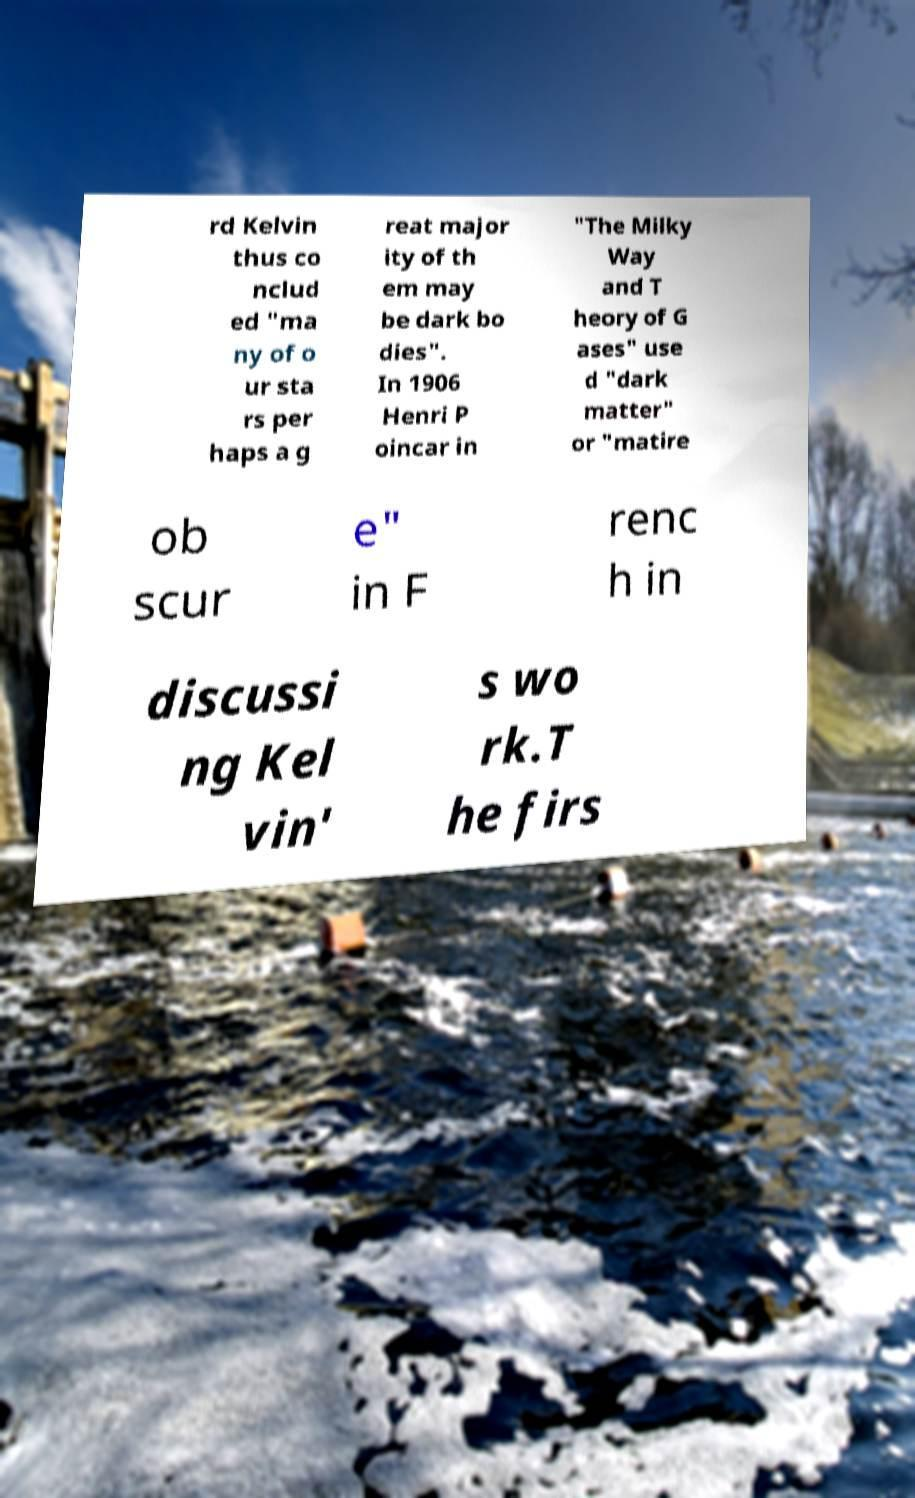Please read and relay the text visible in this image. What does it say? rd Kelvin thus co nclud ed "ma ny of o ur sta rs per haps a g reat major ity of th em may be dark bo dies". In 1906 Henri P oincar in "The Milky Way and T heory of G ases" use d "dark matter" or "matire ob scur e" in F renc h in discussi ng Kel vin' s wo rk.T he firs 